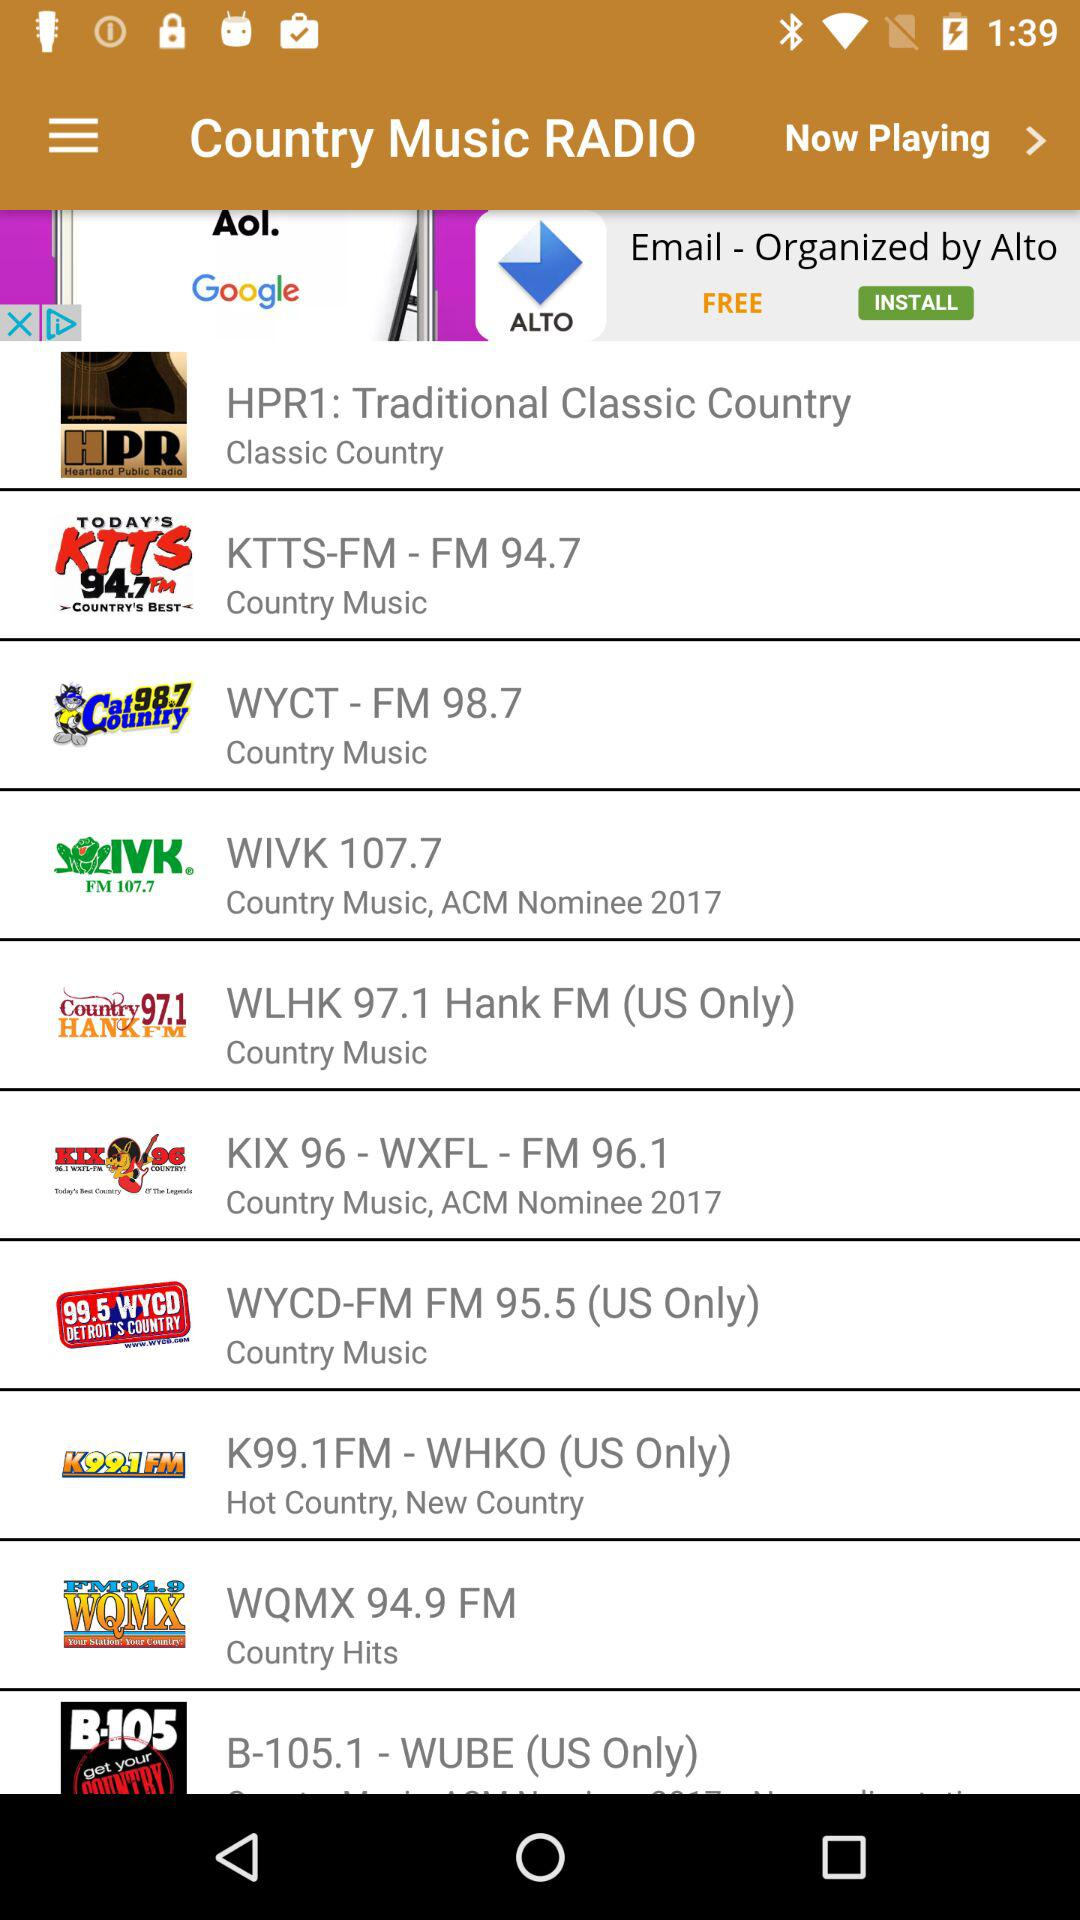What is the name of the application? The name of the application is "Country Music RADIO". 